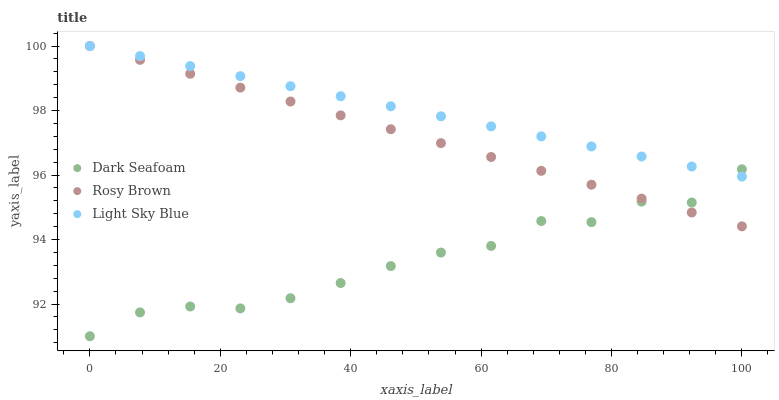Does Dark Seafoam have the minimum area under the curve?
Answer yes or no. Yes. Does Light Sky Blue have the maximum area under the curve?
Answer yes or no. Yes. Does Rosy Brown have the minimum area under the curve?
Answer yes or no. No. Does Rosy Brown have the maximum area under the curve?
Answer yes or no. No. Is Light Sky Blue the smoothest?
Answer yes or no. Yes. Is Dark Seafoam the roughest?
Answer yes or no. Yes. Is Rosy Brown the smoothest?
Answer yes or no. No. Is Rosy Brown the roughest?
Answer yes or no. No. Does Dark Seafoam have the lowest value?
Answer yes or no. Yes. Does Rosy Brown have the lowest value?
Answer yes or no. No. Does Light Sky Blue have the highest value?
Answer yes or no. Yes. Does Light Sky Blue intersect Dark Seafoam?
Answer yes or no. Yes. Is Light Sky Blue less than Dark Seafoam?
Answer yes or no. No. Is Light Sky Blue greater than Dark Seafoam?
Answer yes or no. No. 